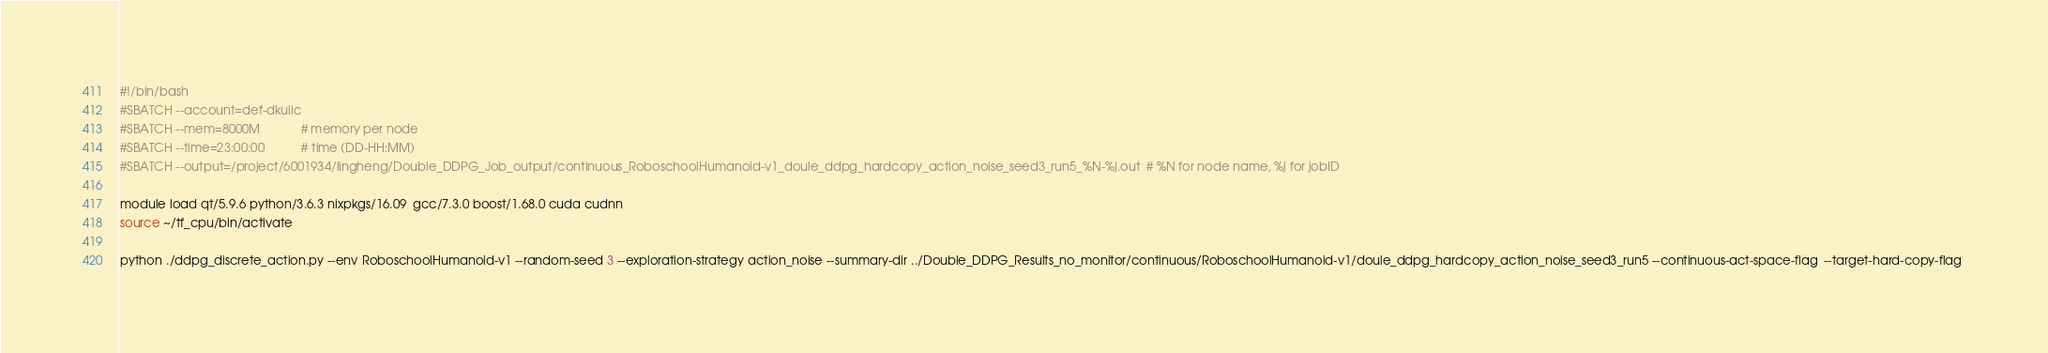Convert code to text. <code><loc_0><loc_0><loc_500><loc_500><_Bash_>#!/bin/bash
#SBATCH --account=def-dkulic
#SBATCH --mem=8000M            # memory per node
#SBATCH --time=23:00:00           # time (DD-HH:MM)
#SBATCH --output=/project/6001934/lingheng/Double_DDPG_Job_output/continuous_RoboschoolHumanoid-v1_doule_ddpg_hardcopy_action_noise_seed3_run5_%N-%j.out  # %N for node name, %j for jobID

module load qt/5.9.6 python/3.6.3 nixpkgs/16.09  gcc/7.3.0 boost/1.68.0 cuda cudnn
source ~/tf_cpu/bin/activate

python ./ddpg_discrete_action.py --env RoboschoolHumanoid-v1 --random-seed 3 --exploration-strategy action_noise --summary-dir ../Double_DDPG_Results_no_monitor/continuous/RoboschoolHumanoid-v1/doule_ddpg_hardcopy_action_noise_seed3_run5 --continuous-act-space-flag  --target-hard-copy-flag 

</code> 